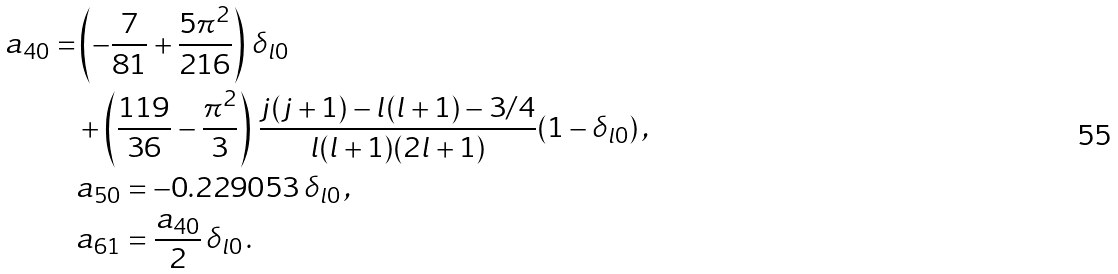Convert formula to latex. <formula><loc_0><loc_0><loc_500><loc_500>a _ { 4 0 } = & \left ( - \frac { 7 } { 8 1 } + \frac { 5 \pi ^ { 2 } } { 2 1 6 } \right ) \, \delta _ { l 0 } \\ & + \left ( \frac { 1 1 9 } { 3 6 } - \frac { \pi ^ { 2 } } { 3 } \right ) \, \frac { j ( j + 1 ) - l ( l + 1 ) - 3 / 4 } { l ( l + 1 ) ( 2 l + 1 ) } ( 1 - \delta _ { l 0 } ) \, , \\ & a _ { 5 0 } = - 0 . 2 2 9 0 5 3 \, \delta _ { l 0 } \, , \\ & a _ { 6 1 } = \frac { a _ { 4 0 } } 2 \, \delta _ { l 0 } \, .</formula> 